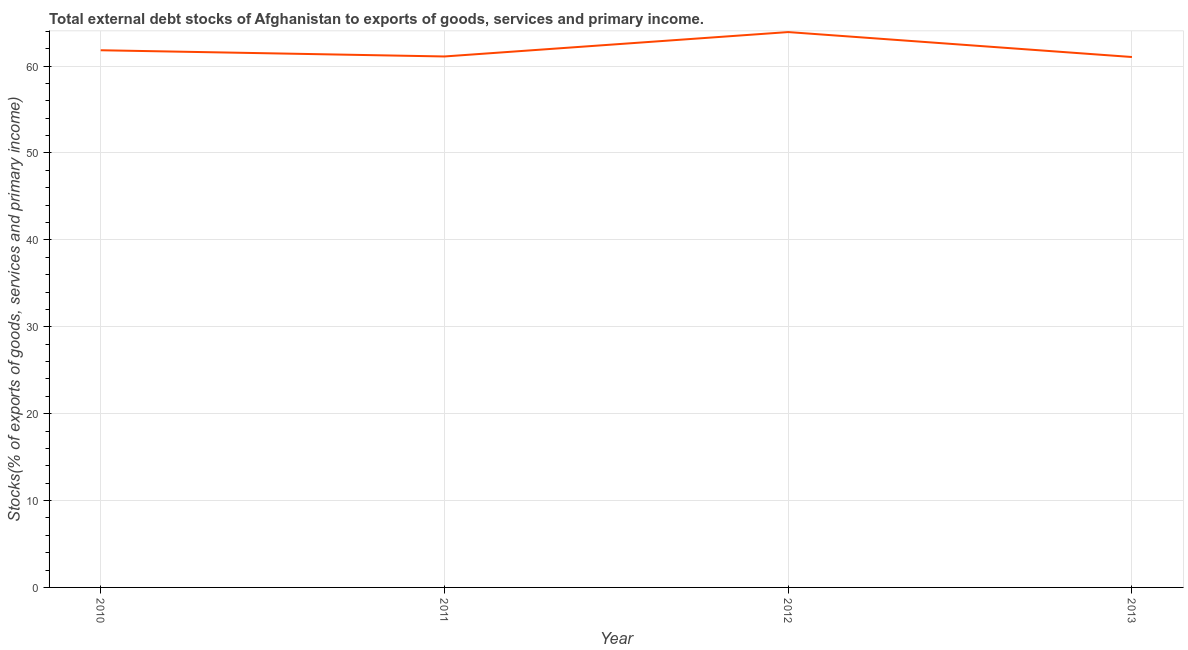What is the external debt stocks in 2013?
Your answer should be compact. 61.04. Across all years, what is the maximum external debt stocks?
Offer a very short reply. 63.91. Across all years, what is the minimum external debt stocks?
Ensure brevity in your answer.  61.04. In which year was the external debt stocks maximum?
Offer a very short reply. 2012. In which year was the external debt stocks minimum?
Offer a terse response. 2013. What is the sum of the external debt stocks?
Provide a succinct answer. 247.89. What is the difference between the external debt stocks in 2011 and 2013?
Keep it short and to the point. 0.06. What is the average external debt stocks per year?
Provide a succinct answer. 61.97. What is the median external debt stocks?
Offer a very short reply. 61.46. In how many years, is the external debt stocks greater than 10 %?
Ensure brevity in your answer.  4. Do a majority of the years between 2013 and 2010 (inclusive) have external debt stocks greater than 40 %?
Your answer should be compact. Yes. What is the ratio of the external debt stocks in 2011 to that in 2013?
Provide a short and direct response. 1. Is the external debt stocks in 2011 less than that in 2013?
Ensure brevity in your answer.  No. Is the difference between the external debt stocks in 2011 and 2013 greater than the difference between any two years?
Your answer should be compact. No. What is the difference between the highest and the second highest external debt stocks?
Your response must be concise. 2.09. Is the sum of the external debt stocks in 2011 and 2013 greater than the maximum external debt stocks across all years?
Offer a very short reply. Yes. What is the difference between the highest and the lowest external debt stocks?
Your response must be concise. 2.87. How many lines are there?
Give a very brief answer. 1. How many years are there in the graph?
Your response must be concise. 4. Does the graph contain any zero values?
Offer a very short reply. No. Does the graph contain grids?
Give a very brief answer. Yes. What is the title of the graph?
Offer a terse response. Total external debt stocks of Afghanistan to exports of goods, services and primary income. What is the label or title of the X-axis?
Offer a terse response. Year. What is the label or title of the Y-axis?
Ensure brevity in your answer.  Stocks(% of exports of goods, services and primary income). What is the Stocks(% of exports of goods, services and primary income) of 2010?
Make the answer very short. 61.82. What is the Stocks(% of exports of goods, services and primary income) of 2011?
Give a very brief answer. 61.11. What is the Stocks(% of exports of goods, services and primary income) in 2012?
Make the answer very short. 63.91. What is the Stocks(% of exports of goods, services and primary income) of 2013?
Your answer should be compact. 61.04. What is the difference between the Stocks(% of exports of goods, services and primary income) in 2010 and 2011?
Ensure brevity in your answer.  0.72. What is the difference between the Stocks(% of exports of goods, services and primary income) in 2010 and 2012?
Make the answer very short. -2.09. What is the difference between the Stocks(% of exports of goods, services and primary income) in 2010 and 2013?
Provide a short and direct response. 0.78. What is the difference between the Stocks(% of exports of goods, services and primary income) in 2011 and 2012?
Make the answer very short. -2.81. What is the difference between the Stocks(% of exports of goods, services and primary income) in 2011 and 2013?
Make the answer very short. 0.06. What is the difference between the Stocks(% of exports of goods, services and primary income) in 2012 and 2013?
Ensure brevity in your answer.  2.87. What is the ratio of the Stocks(% of exports of goods, services and primary income) in 2010 to that in 2011?
Offer a terse response. 1.01. What is the ratio of the Stocks(% of exports of goods, services and primary income) in 2011 to that in 2012?
Make the answer very short. 0.96. What is the ratio of the Stocks(% of exports of goods, services and primary income) in 2012 to that in 2013?
Ensure brevity in your answer.  1.05. 